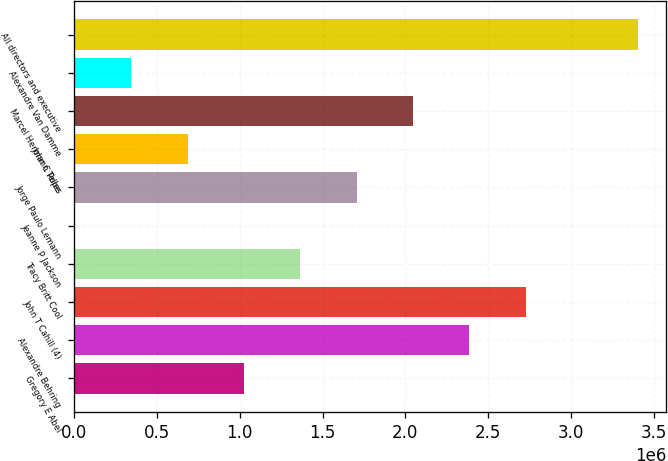Convert chart to OTSL. <chart><loc_0><loc_0><loc_500><loc_500><bar_chart><fcel>Gregory E Abel<fcel>Alexandre Behring<fcel>John T Cahill (4)<fcel>Tracy Britt Cool<fcel>Jeanne P Jackson<fcel>Jorge Paulo Lemann<fcel>John C Pope<fcel>Marcel Hermann Telles<fcel>Alexandre Van Damme<fcel>All directors and executive<nl><fcel>1.02495e+06<fcel>2.38583e+06<fcel>2.72606e+06<fcel>1.36517e+06<fcel>4280<fcel>1.70539e+06<fcel>684724<fcel>2.04561e+06<fcel>344502<fcel>3.4065e+06<nl></chart> 